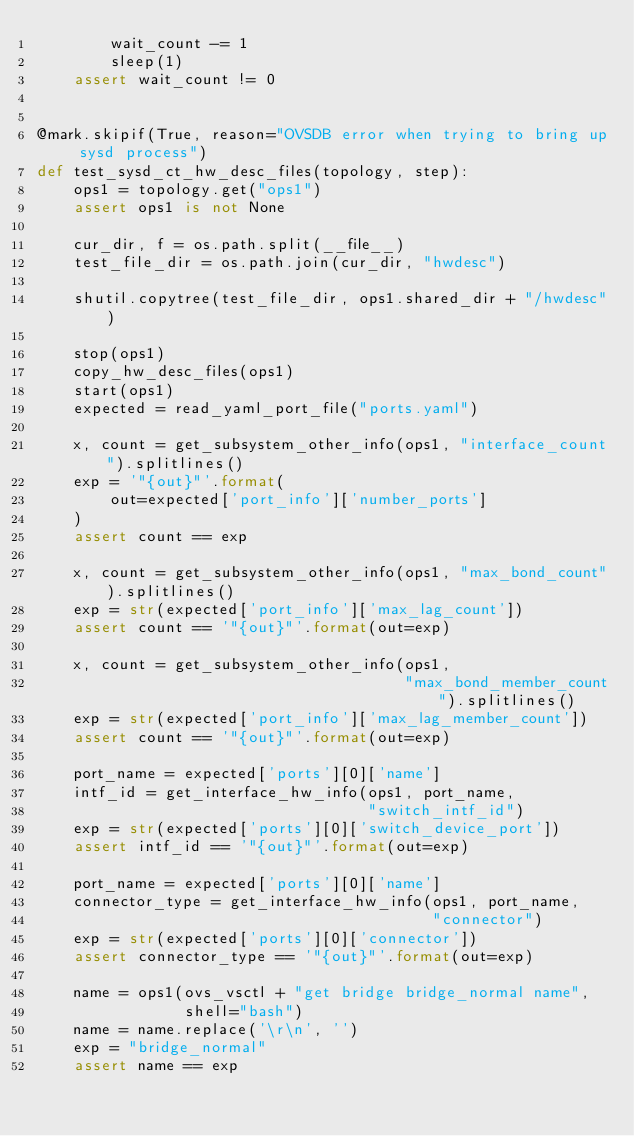<code> <loc_0><loc_0><loc_500><loc_500><_Python_>        wait_count -= 1
        sleep(1)
    assert wait_count != 0


@mark.skipif(True, reason="OVSDB error when trying to bring up sysd process")
def test_sysd_ct_hw_desc_files(topology, step):
    ops1 = topology.get("ops1")
    assert ops1 is not None

    cur_dir, f = os.path.split(__file__)
    test_file_dir = os.path.join(cur_dir, "hwdesc")

    shutil.copytree(test_file_dir, ops1.shared_dir + "/hwdesc")

    stop(ops1)
    copy_hw_desc_files(ops1)
    start(ops1)
    expected = read_yaml_port_file("ports.yaml")

    x, count = get_subsystem_other_info(ops1, "interface_count").splitlines()
    exp = '"{out}"'.format(
        out=expected['port_info']['number_ports']
    )
    assert count == exp

    x, count = get_subsystem_other_info(ops1, "max_bond_count").splitlines()
    exp = str(expected['port_info']['max_lag_count'])
    assert count == '"{out}"'.format(out=exp)

    x, count = get_subsystem_other_info(ops1,
                                        "max_bond_member_count").splitlines()
    exp = str(expected['port_info']['max_lag_member_count'])
    assert count == '"{out}"'.format(out=exp)

    port_name = expected['ports'][0]['name']
    intf_id = get_interface_hw_info(ops1, port_name,
                                    "switch_intf_id")
    exp = str(expected['ports'][0]['switch_device_port'])
    assert intf_id == '"{out}"'.format(out=exp)

    port_name = expected['ports'][0]['name']
    connector_type = get_interface_hw_info(ops1, port_name,
                                           "connector")
    exp = str(expected['ports'][0]['connector'])
    assert connector_type == '"{out}"'.format(out=exp)

    name = ops1(ovs_vsctl + "get bridge bridge_normal name",
                shell="bash")
    name = name.replace('\r\n', '')
    exp = "bridge_normal"
    assert name == exp
</code> 